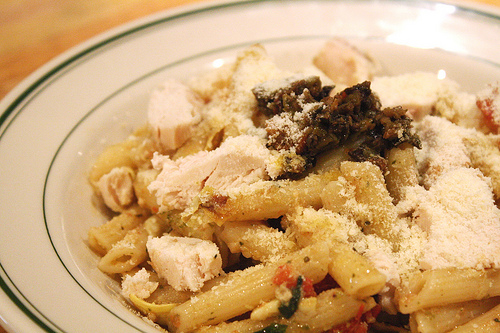<image>
Can you confirm if the chicken is next to the plate? No. The chicken is not positioned next to the plate. They are located in different areas of the scene. Is there a food on the table? Yes. Looking at the image, I can see the food is positioned on top of the table, with the table providing support. Is the food on the plate? Yes. Looking at the image, I can see the food is positioned on top of the plate, with the plate providing support. 